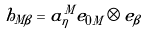<formula> <loc_0><loc_0><loc_500><loc_500>h _ { M \beta } = a _ { \eta } ^ { M } e _ { 0 M } \otimes e _ { \beta }</formula> 